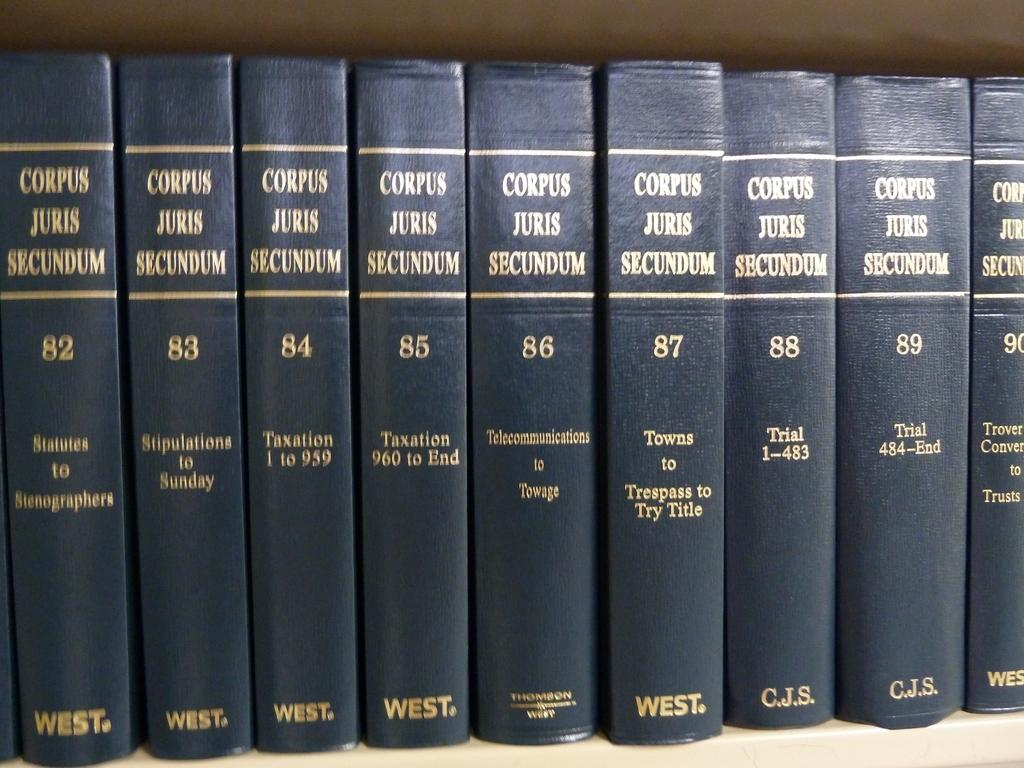<image>
Summarize the visual content of the image. Multiple volumes of Corupus Juris Secundum lined up on a bookshelf. 